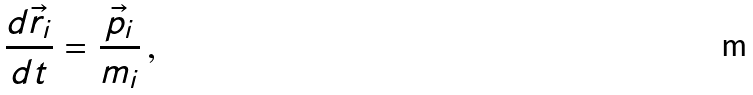<formula> <loc_0><loc_0><loc_500><loc_500>\frac { d \vec { r } _ { i } } { d t } = \frac { \vec { p } _ { i } } { m _ { i } } \, ,</formula> 